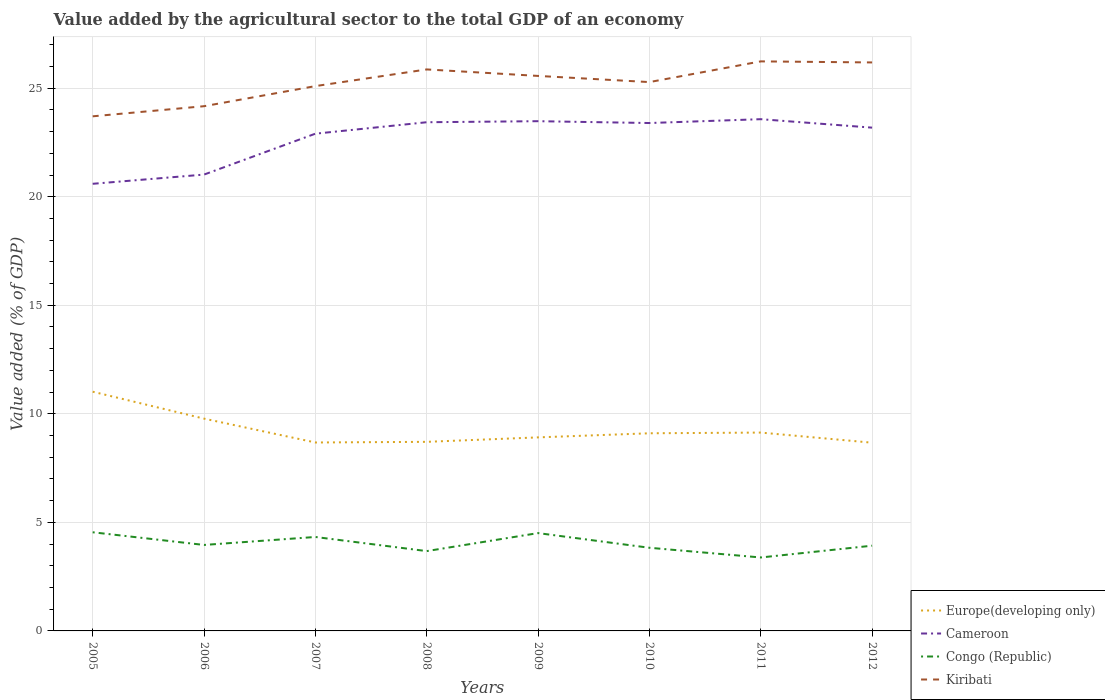How many different coloured lines are there?
Your answer should be compact. 4. Does the line corresponding to Europe(developing only) intersect with the line corresponding to Cameroon?
Give a very brief answer. No. Is the number of lines equal to the number of legend labels?
Give a very brief answer. Yes. Across all years, what is the maximum value added by the agricultural sector to the total GDP in Congo (Republic)?
Keep it short and to the point. 3.38. In which year was the value added by the agricultural sector to the total GDP in Cameroon maximum?
Your answer should be compact. 2005. What is the total value added by the agricultural sector to the total GDP in Congo (Republic) in the graph?
Keep it short and to the point. -0.37. What is the difference between the highest and the second highest value added by the agricultural sector to the total GDP in Europe(developing only)?
Offer a very short reply. 2.35. What is the difference between the highest and the lowest value added by the agricultural sector to the total GDP in Cameroon?
Keep it short and to the point. 6. How many lines are there?
Make the answer very short. 4. What is the difference between two consecutive major ticks on the Y-axis?
Your answer should be compact. 5. Does the graph contain any zero values?
Ensure brevity in your answer.  No. Does the graph contain grids?
Offer a very short reply. Yes. Where does the legend appear in the graph?
Provide a short and direct response. Bottom right. What is the title of the graph?
Offer a terse response. Value added by the agricultural sector to the total GDP of an economy. Does "World" appear as one of the legend labels in the graph?
Provide a succinct answer. No. What is the label or title of the X-axis?
Provide a short and direct response. Years. What is the label or title of the Y-axis?
Offer a terse response. Value added (% of GDP). What is the Value added (% of GDP) of Europe(developing only) in 2005?
Your answer should be very brief. 11.02. What is the Value added (% of GDP) in Cameroon in 2005?
Your answer should be compact. 20.59. What is the Value added (% of GDP) of Congo (Republic) in 2005?
Your response must be concise. 4.54. What is the Value added (% of GDP) in Kiribati in 2005?
Your answer should be compact. 23.7. What is the Value added (% of GDP) in Europe(developing only) in 2006?
Give a very brief answer. 9.78. What is the Value added (% of GDP) of Cameroon in 2006?
Your response must be concise. 21.02. What is the Value added (% of GDP) of Congo (Republic) in 2006?
Provide a short and direct response. 3.96. What is the Value added (% of GDP) in Kiribati in 2006?
Your response must be concise. 24.17. What is the Value added (% of GDP) in Europe(developing only) in 2007?
Offer a terse response. 8.68. What is the Value added (% of GDP) in Cameroon in 2007?
Your response must be concise. 22.9. What is the Value added (% of GDP) of Congo (Republic) in 2007?
Offer a terse response. 4.33. What is the Value added (% of GDP) of Kiribati in 2007?
Make the answer very short. 25.09. What is the Value added (% of GDP) of Europe(developing only) in 2008?
Provide a succinct answer. 8.71. What is the Value added (% of GDP) of Cameroon in 2008?
Keep it short and to the point. 23.43. What is the Value added (% of GDP) of Congo (Republic) in 2008?
Your answer should be compact. 3.68. What is the Value added (% of GDP) of Kiribati in 2008?
Provide a short and direct response. 25.86. What is the Value added (% of GDP) in Europe(developing only) in 2009?
Offer a terse response. 8.91. What is the Value added (% of GDP) in Cameroon in 2009?
Offer a terse response. 23.48. What is the Value added (% of GDP) in Congo (Republic) in 2009?
Provide a short and direct response. 4.51. What is the Value added (% of GDP) of Kiribati in 2009?
Offer a very short reply. 25.56. What is the Value added (% of GDP) of Europe(developing only) in 2010?
Offer a terse response. 9.1. What is the Value added (% of GDP) of Cameroon in 2010?
Your answer should be compact. 23.39. What is the Value added (% of GDP) of Congo (Republic) in 2010?
Your response must be concise. 3.83. What is the Value added (% of GDP) in Kiribati in 2010?
Give a very brief answer. 25.28. What is the Value added (% of GDP) in Europe(developing only) in 2011?
Your answer should be compact. 9.14. What is the Value added (% of GDP) in Cameroon in 2011?
Offer a very short reply. 23.57. What is the Value added (% of GDP) of Congo (Republic) in 2011?
Offer a very short reply. 3.38. What is the Value added (% of GDP) of Kiribati in 2011?
Keep it short and to the point. 26.23. What is the Value added (% of GDP) of Europe(developing only) in 2012?
Provide a succinct answer. 8.67. What is the Value added (% of GDP) in Cameroon in 2012?
Give a very brief answer. 23.18. What is the Value added (% of GDP) in Congo (Republic) in 2012?
Keep it short and to the point. 3.93. What is the Value added (% of GDP) of Kiribati in 2012?
Your response must be concise. 26.18. Across all years, what is the maximum Value added (% of GDP) of Europe(developing only)?
Your response must be concise. 11.02. Across all years, what is the maximum Value added (% of GDP) in Cameroon?
Give a very brief answer. 23.57. Across all years, what is the maximum Value added (% of GDP) of Congo (Republic)?
Keep it short and to the point. 4.54. Across all years, what is the maximum Value added (% of GDP) of Kiribati?
Make the answer very short. 26.23. Across all years, what is the minimum Value added (% of GDP) in Europe(developing only)?
Your answer should be very brief. 8.67. Across all years, what is the minimum Value added (% of GDP) in Cameroon?
Ensure brevity in your answer.  20.59. Across all years, what is the minimum Value added (% of GDP) in Congo (Republic)?
Make the answer very short. 3.38. Across all years, what is the minimum Value added (% of GDP) in Kiribati?
Your answer should be very brief. 23.7. What is the total Value added (% of GDP) of Europe(developing only) in the graph?
Make the answer very short. 74.01. What is the total Value added (% of GDP) in Cameroon in the graph?
Keep it short and to the point. 181.57. What is the total Value added (% of GDP) of Congo (Republic) in the graph?
Keep it short and to the point. 32.15. What is the total Value added (% of GDP) of Kiribati in the graph?
Give a very brief answer. 202.09. What is the difference between the Value added (% of GDP) of Europe(developing only) in 2005 and that in 2006?
Provide a succinct answer. 1.24. What is the difference between the Value added (% of GDP) of Cameroon in 2005 and that in 2006?
Offer a very short reply. -0.42. What is the difference between the Value added (% of GDP) in Congo (Republic) in 2005 and that in 2006?
Your response must be concise. 0.58. What is the difference between the Value added (% of GDP) of Kiribati in 2005 and that in 2006?
Offer a terse response. -0.47. What is the difference between the Value added (% of GDP) in Europe(developing only) in 2005 and that in 2007?
Provide a short and direct response. 2.34. What is the difference between the Value added (% of GDP) of Cameroon in 2005 and that in 2007?
Give a very brief answer. -2.31. What is the difference between the Value added (% of GDP) of Congo (Republic) in 2005 and that in 2007?
Offer a terse response. 0.22. What is the difference between the Value added (% of GDP) in Kiribati in 2005 and that in 2007?
Offer a very short reply. -1.39. What is the difference between the Value added (% of GDP) in Europe(developing only) in 2005 and that in 2008?
Keep it short and to the point. 2.31. What is the difference between the Value added (% of GDP) of Cameroon in 2005 and that in 2008?
Provide a short and direct response. -2.84. What is the difference between the Value added (% of GDP) of Congo (Republic) in 2005 and that in 2008?
Make the answer very short. 0.87. What is the difference between the Value added (% of GDP) of Kiribati in 2005 and that in 2008?
Offer a terse response. -2.16. What is the difference between the Value added (% of GDP) in Europe(developing only) in 2005 and that in 2009?
Offer a very short reply. 2.1. What is the difference between the Value added (% of GDP) of Cameroon in 2005 and that in 2009?
Your answer should be very brief. -2.88. What is the difference between the Value added (% of GDP) of Congo (Republic) in 2005 and that in 2009?
Make the answer very short. 0.04. What is the difference between the Value added (% of GDP) in Kiribati in 2005 and that in 2009?
Provide a succinct answer. -1.86. What is the difference between the Value added (% of GDP) in Europe(developing only) in 2005 and that in 2010?
Provide a succinct answer. 1.91. What is the difference between the Value added (% of GDP) in Cameroon in 2005 and that in 2010?
Your response must be concise. -2.8. What is the difference between the Value added (% of GDP) in Congo (Republic) in 2005 and that in 2010?
Make the answer very short. 0.71. What is the difference between the Value added (% of GDP) of Kiribati in 2005 and that in 2010?
Give a very brief answer. -1.58. What is the difference between the Value added (% of GDP) in Europe(developing only) in 2005 and that in 2011?
Keep it short and to the point. 1.88. What is the difference between the Value added (% of GDP) of Cameroon in 2005 and that in 2011?
Provide a short and direct response. -2.98. What is the difference between the Value added (% of GDP) of Congo (Republic) in 2005 and that in 2011?
Provide a short and direct response. 1.16. What is the difference between the Value added (% of GDP) in Kiribati in 2005 and that in 2011?
Make the answer very short. -2.53. What is the difference between the Value added (% of GDP) of Europe(developing only) in 2005 and that in 2012?
Your response must be concise. 2.35. What is the difference between the Value added (% of GDP) in Cameroon in 2005 and that in 2012?
Provide a short and direct response. -2.59. What is the difference between the Value added (% of GDP) in Congo (Republic) in 2005 and that in 2012?
Offer a very short reply. 0.62. What is the difference between the Value added (% of GDP) of Kiribati in 2005 and that in 2012?
Ensure brevity in your answer.  -2.48. What is the difference between the Value added (% of GDP) in Europe(developing only) in 2006 and that in 2007?
Provide a short and direct response. 1.1. What is the difference between the Value added (% of GDP) in Cameroon in 2006 and that in 2007?
Ensure brevity in your answer.  -1.88. What is the difference between the Value added (% of GDP) in Congo (Republic) in 2006 and that in 2007?
Give a very brief answer. -0.37. What is the difference between the Value added (% of GDP) in Kiribati in 2006 and that in 2007?
Make the answer very short. -0.93. What is the difference between the Value added (% of GDP) of Europe(developing only) in 2006 and that in 2008?
Ensure brevity in your answer.  1.07. What is the difference between the Value added (% of GDP) in Cameroon in 2006 and that in 2008?
Ensure brevity in your answer.  -2.41. What is the difference between the Value added (% of GDP) in Congo (Republic) in 2006 and that in 2008?
Your response must be concise. 0.28. What is the difference between the Value added (% of GDP) of Kiribati in 2006 and that in 2008?
Provide a succinct answer. -1.69. What is the difference between the Value added (% of GDP) in Europe(developing only) in 2006 and that in 2009?
Your answer should be very brief. 0.86. What is the difference between the Value added (% of GDP) in Cameroon in 2006 and that in 2009?
Offer a terse response. -2.46. What is the difference between the Value added (% of GDP) in Congo (Republic) in 2006 and that in 2009?
Provide a short and direct response. -0.55. What is the difference between the Value added (% of GDP) of Kiribati in 2006 and that in 2009?
Give a very brief answer. -1.4. What is the difference between the Value added (% of GDP) in Europe(developing only) in 2006 and that in 2010?
Ensure brevity in your answer.  0.67. What is the difference between the Value added (% of GDP) of Cameroon in 2006 and that in 2010?
Make the answer very short. -2.37. What is the difference between the Value added (% of GDP) of Congo (Republic) in 2006 and that in 2010?
Your answer should be very brief. 0.13. What is the difference between the Value added (% of GDP) of Kiribati in 2006 and that in 2010?
Offer a very short reply. -1.11. What is the difference between the Value added (% of GDP) of Europe(developing only) in 2006 and that in 2011?
Your answer should be compact. 0.64. What is the difference between the Value added (% of GDP) of Cameroon in 2006 and that in 2011?
Your answer should be compact. -2.55. What is the difference between the Value added (% of GDP) in Congo (Republic) in 2006 and that in 2011?
Give a very brief answer. 0.58. What is the difference between the Value added (% of GDP) of Kiribati in 2006 and that in 2011?
Make the answer very short. -2.06. What is the difference between the Value added (% of GDP) in Europe(developing only) in 2006 and that in 2012?
Offer a very short reply. 1.11. What is the difference between the Value added (% of GDP) in Cameroon in 2006 and that in 2012?
Ensure brevity in your answer.  -2.16. What is the difference between the Value added (% of GDP) in Congo (Republic) in 2006 and that in 2012?
Make the answer very short. 0.03. What is the difference between the Value added (% of GDP) of Kiribati in 2006 and that in 2012?
Keep it short and to the point. -2.02. What is the difference between the Value added (% of GDP) in Europe(developing only) in 2007 and that in 2008?
Keep it short and to the point. -0.03. What is the difference between the Value added (% of GDP) in Cameroon in 2007 and that in 2008?
Your response must be concise. -0.53. What is the difference between the Value added (% of GDP) of Congo (Republic) in 2007 and that in 2008?
Keep it short and to the point. 0.65. What is the difference between the Value added (% of GDP) in Kiribati in 2007 and that in 2008?
Provide a succinct answer. -0.77. What is the difference between the Value added (% of GDP) of Europe(developing only) in 2007 and that in 2009?
Your answer should be compact. -0.23. What is the difference between the Value added (% of GDP) in Cameroon in 2007 and that in 2009?
Ensure brevity in your answer.  -0.58. What is the difference between the Value added (% of GDP) of Congo (Republic) in 2007 and that in 2009?
Provide a succinct answer. -0.18. What is the difference between the Value added (% of GDP) of Kiribati in 2007 and that in 2009?
Offer a terse response. -0.47. What is the difference between the Value added (% of GDP) in Europe(developing only) in 2007 and that in 2010?
Offer a very short reply. -0.42. What is the difference between the Value added (% of GDP) of Cameroon in 2007 and that in 2010?
Your answer should be very brief. -0.49. What is the difference between the Value added (% of GDP) of Congo (Republic) in 2007 and that in 2010?
Offer a very short reply. 0.5. What is the difference between the Value added (% of GDP) of Kiribati in 2007 and that in 2010?
Ensure brevity in your answer.  -0.19. What is the difference between the Value added (% of GDP) in Europe(developing only) in 2007 and that in 2011?
Make the answer very short. -0.46. What is the difference between the Value added (% of GDP) of Cameroon in 2007 and that in 2011?
Offer a very short reply. -0.67. What is the difference between the Value added (% of GDP) of Congo (Republic) in 2007 and that in 2011?
Your answer should be very brief. 0.94. What is the difference between the Value added (% of GDP) in Kiribati in 2007 and that in 2011?
Offer a very short reply. -1.14. What is the difference between the Value added (% of GDP) in Europe(developing only) in 2007 and that in 2012?
Your response must be concise. 0.01. What is the difference between the Value added (% of GDP) of Cameroon in 2007 and that in 2012?
Provide a short and direct response. -0.28. What is the difference between the Value added (% of GDP) of Congo (Republic) in 2007 and that in 2012?
Offer a terse response. 0.4. What is the difference between the Value added (% of GDP) in Kiribati in 2007 and that in 2012?
Make the answer very short. -1.09. What is the difference between the Value added (% of GDP) in Europe(developing only) in 2008 and that in 2009?
Offer a very short reply. -0.21. What is the difference between the Value added (% of GDP) of Cameroon in 2008 and that in 2009?
Make the answer very short. -0.05. What is the difference between the Value added (% of GDP) of Congo (Republic) in 2008 and that in 2009?
Your answer should be compact. -0.83. What is the difference between the Value added (% of GDP) in Kiribati in 2008 and that in 2009?
Keep it short and to the point. 0.3. What is the difference between the Value added (% of GDP) in Europe(developing only) in 2008 and that in 2010?
Your answer should be very brief. -0.39. What is the difference between the Value added (% of GDP) in Cameroon in 2008 and that in 2010?
Make the answer very short. 0.04. What is the difference between the Value added (% of GDP) of Congo (Republic) in 2008 and that in 2010?
Keep it short and to the point. -0.15. What is the difference between the Value added (% of GDP) of Kiribati in 2008 and that in 2010?
Offer a terse response. 0.58. What is the difference between the Value added (% of GDP) of Europe(developing only) in 2008 and that in 2011?
Ensure brevity in your answer.  -0.43. What is the difference between the Value added (% of GDP) in Cameroon in 2008 and that in 2011?
Provide a succinct answer. -0.14. What is the difference between the Value added (% of GDP) of Congo (Republic) in 2008 and that in 2011?
Give a very brief answer. 0.29. What is the difference between the Value added (% of GDP) in Kiribati in 2008 and that in 2011?
Your response must be concise. -0.37. What is the difference between the Value added (% of GDP) of Europe(developing only) in 2008 and that in 2012?
Your answer should be very brief. 0.04. What is the difference between the Value added (% of GDP) of Cameroon in 2008 and that in 2012?
Give a very brief answer. 0.25. What is the difference between the Value added (% of GDP) in Congo (Republic) in 2008 and that in 2012?
Your answer should be very brief. -0.25. What is the difference between the Value added (% of GDP) in Kiribati in 2008 and that in 2012?
Make the answer very short. -0.32. What is the difference between the Value added (% of GDP) of Europe(developing only) in 2009 and that in 2010?
Ensure brevity in your answer.  -0.19. What is the difference between the Value added (% of GDP) of Cameroon in 2009 and that in 2010?
Provide a short and direct response. 0.08. What is the difference between the Value added (% of GDP) in Congo (Republic) in 2009 and that in 2010?
Ensure brevity in your answer.  0.68. What is the difference between the Value added (% of GDP) in Kiribati in 2009 and that in 2010?
Offer a terse response. 0.28. What is the difference between the Value added (% of GDP) of Europe(developing only) in 2009 and that in 2011?
Your answer should be very brief. -0.22. What is the difference between the Value added (% of GDP) of Cameroon in 2009 and that in 2011?
Offer a very short reply. -0.09. What is the difference between the Value added (% of GDP) of Congo (Republic) in 2009 and that in 2011?
Make the answer very short. 1.12. What is the difference between the Value added (% of GDP) in Kiribati in 2009 and that in 2011?
Provide a short and direct response. -0.67. What is the difference between the Value added (% of GDP) of Europe(developing only) in 2009 and that in 2012?
Provide a short and direct response. 0.25. What is the difference between the Value added (% of GDP) of Cameroon in 2009 and that in 2012?
Your answer should be compact. 0.3. What is the difference between the Value added (% of GDP) in Congo (Republic) in 2009 and that in 2012?
Make the answer very short. 0.58. What is the difference between the Value added (% of GDP) in Kiribati in 2009 and that in 2012?
Provide a short and direct response. -0.62. What is the difference between the Value added (% of GDP) in Europe(developing only) in 2010 and that in 2011?
Offer a very short reply. -0.03. What is the difference between the Value added (% of GDP) in Cameroon in 2010 and that in 2011?
Your answer should be very brief. -0.18. What is the difference between the Value added (% of GDP) in Congo (Republic) in 2010 and that in 2011?
Give a very brief answer. 0.45. What is the difference between the Value added (% of GDP) of Kiribati in 2010 and that in 2011?
Give a very brief answer. -0.95. What is the difference between the Value added (% of GDP) of Europe(developing only) in 2010 and that in 2012?
Give a very brief answer. 0.43. What is the difference between the Value added (% of GDP) of Cameroon in 2010 and that in 2012?
Offer a very short reply. 0.21. What is the difference between the Value added (% of GDP) of Congo (Republic) in 2010 and that in 2012?
Give a very brief answer. -0.1. What is the difference between the Value added (% of GDP) of Kiribati in 2010 and that in 2012?
Provide a succinct answer. -0.9. What is the difference between the Value added (% of GDP) of Europe(developing only) in 2011 and that in 2012?
Offer a very short reply. 0.47. What is the difference between the Value added (% of GDP) of Cameroon in 2011 and that in 2012?
Your response must be concise. 0.39. What is the difference between the Value added (% of GDP) of Congo (Republic) in 2011 and that in 2012?
Keep it short and to the point. -0.54. What is the difference between the Value added (% of GDP) of Kiribati in 2011 and that in 2012?
Give a very brief answer. 0.05. What is the difference between the Value added (% of GDP) of Europe(developing only) in 2005 and the Value added (% of GDP) of Cameroon in 2006?
Give a very brief answer. -10. What is the difference between the Value added (% of GDP) in Europe(developing only) in 2005 and the Value added (% of GDP) in Congo (Republic) in 2006?
Your answer should be very brief. 7.06. What is the difference between the Value added (% of GDP) of Europe(developing only) in 2005 and the Value added (% of GDP) of Kiribati in 2006?
Provide a succinct answer. -13.15. What is the difference between the Value added (% of GDP) in Cameroon in 2005 and the Value added (% of GDP) in Congo (Republic) in 2006?
Your answer should be very brief. 16.63. What is the difference between the Value added (% of GDP) in Cameroon in 2005 and the Value added (% of GDP) in Kiribati in 2006?
Keep it short and to the point. -3.57. What is the difference between the Value added (% of GDP) of Congo (Republic) in 2005 and the Value added (% of GDP) of Kiribati in 2006?
Offer a terse response. -19.62. What is the difference between the Value added (% of GDP) in Europe(developing only) in 2005 and the Value added (% of GDP) in Cameroon in 2007?
Provide a short and direct response. -11.88. What is the difference between the Value added (% of GDP) in Europe(developing only) in 2005 and the Value added (% of GDP) in Congo (Republic) in 2007?
Provide a short and direct response. 6.69. What is the difference between the Value added (% of GDP) of Europe(developing only) in 2005 and the Value added (% of GDP) of Kiribati in 2007?
Provide a succinct answer. -14.08. What is the difference between the Value added (% of GDP) in Cameroon in 2005 and the Value added (% of GDP) in Congo (Republic) in 2007?
Make the answer very short. 16.27. What is the difference between the Value added (% of GDP) of Cameroon in 2005 and the Value added (% of GDP) of Kiribati in 2007?
Provide a succinct answer. -4.5. What is the difference between the Value added (% of GDP) in Congo (Republic) in 2005 and the Value added (% of GDP) in Kiribati in 2007?
Make the answer very short. -20.55. What is the difference between the Value added (% of GDP) of Europe(developing only) in 2005 and the Value added (% of GDP) of Cameroon in 2008?
Your answer should be very brief. -12.41. What is the difference between the Value added (% of GDP) in Europe(developing only) in 2005 and the Value added (% of GDP) in Congo (Republic) in 2008?
Keep it short and to the point. 7.34. What is the difference between the Value added (% of GDP) in Europe(developing only) in 2005 and the Value added (% of GDP) in Kiribati in 2008?
Offer a very short reply. -14.84. What is the difference between the Value added (% of GDP) in Cameroon in 2005 and the Value added (% of GDP) in Congo (Republic) in 2008?
Provide a succinct answer. 16.92. What is the difference between the Value added (% of GDP) of Cameroon in 2005 and the Value added (% of GDP) of Kiribati in 2008?
Make the answer very short. -5.27. What is the difference between the Value added (% of GDP) in Congo (Republic) in 2005 and the Value added (% of GDP) in Kiribati in 2008?
Your answer should be very brief. -21.32. What is the difference between the Value added (% of GDP) in Europe(developing only) in 2005 and the Value added (% of GDP) in Cameroon in 2009?
Give a very brief answer. -12.46. What is the difference between the Value added (% of GDP) in Europe(developing only) in 2005 and the Value added (% of GDP) in Congo (Republic) in 2009?
Ensure brevity in your answer.  6.51. What is the difference between the Value added (% of GDP) of Europe(developing only) in 2005 and the Value added (% of GDP) of Kiribati in 2009?
Offer a very short reply. -14.55. What is the difference between the Value added (% of GDP) of Cameroon in 2005 and the Value added (% of GDP) of Congo (Republic) in 2009?
Your response must be concise. 16.09. What is the difference between the Value added (% of GDP) of Cameroon in 2005 and the Value added (% of GDP) of Kiribati in 2009?
Your answer should be compact. -4.97. What is the difference between the Value added (% of GDP) in Congo (Republic) in 2005 and the Value added (% of GDP) in Kiribati in 2009?
Your answer should be very brief. -21.02. What is the difference between the Value added (% of GDP) in Europe(developing only) in 2005 and the Value added (% of GDP) in Cameroon in 2010?
Give a very brief answer. -12.38. What is the difference between the Value added (% of GDP) in Europe(developing only) in 2005 and the Value added (% of GDP) in Congo (Republic) in 2010?
Offer a very short reply. 7.19. What is the difference between the Value added (% of GDP) of Europe(developing only) in 2005 and the Value added (% of GDP) of Kiribati in 2010?
Keep it short and to the point. -14.26. What is the difference between the Value added (% of GDP) of Cameroon in 2005 and the Value added (% of GDP) of Congo (Republic) in 2010?
Offer a very short reply. 16.76. What is the difference between the Value added (% of GDP) of Cameroon in 2005 and the Value added (% of GDP) of Kiribati in 2010?
Your response must be concise. -4.68. What is the difference between the Value added (% of GDP) in Congo (Republic) in 2005 and the Value added (% of GDP) in Kiribati in 2010?
Keep it short and to the point. -20.74. What is the difference between the Value added (% of GDP) in Europe(developing only) in 2005 and the Value added (% of GDP) in Cameroon in 2011?
Give a very brief answer. -12.55. What is the difference between the Value added (% of GDP) in Europe(developing only) in 2005 and the Value added (% of GDP) in Congo (Republic) in 2011?
Your response must be concise. 7.64. What is the difference between the Value added (% of GDP) in Europe(developing only) in 2005 and the Value added (% of GDP) in Kiribati in 2011?
Offer a terse response. -15.22. What is the difference between the Value added (% of GDP) in Cameroon in 2005 and the Value added (% of GDP) in Congo (Republic) in 2011?
Your response must be concise. 17.21. What is the difference between the Value added (% of GDP) of Cameroon in 2005 and the Value added (% of GDP) of Kiribati in 2011?
Your response must be concise. -5.64. What is the difference between the Value added (% of GDP) in Congo (Republic) in 2005 and the Value added (% of GDP) in Kiribati in 2011?
Provide a succinct answer. -21.69. What is the difference between the Value added (% of GDP) in Europe(developing only) in 2005 and the Value added (% of GDP) in Cameroon in 2012?
Offer a very short reply. -12.16. What is the difference between the Value added (% of GDP) in Europe(developing only) in 2005 and the Value added (% of GDP) in Congo (Republic) in 2012?
Ensure brevity in your answer.  7.09. What is the difference between the Value added (% of GDP) of Europe(developing only) in 2005 and the Value added (% of GDP) of Kiribati in 2012?
Offer a very short reply. -15.17. What is the difference between the Value added (% of GDP) of Cameroon in 2005 and the Value added (% of GDP) of Congo (Republic) in 2012?
Offer a terse response. 16.67. What is the difference between the Value added (% of GDP) in Cameroon in 2005 and the Value added (% of GDP) in Kiribati in 2012?
Keep it short and to the point. -5.59. What is the difference between the Value added (% of GDP) in Congo (Republic) in 2005 and the Value added (% of GDP) in Kiribati in 2012?
Offer a terse response. -21.64. What is the difference between the Value added (% of GDP) in Europe(developing only) in 2006 and the Value added (% of GDP) in Cameroon in 2007?
Your answer should be very brief. -13.13. What is the difference between the Value added (% of GDP) in Europe(developing only) in 2006 and the Value added (% of GDP) in Congo (Republic) in 2007?
Keep it short and to the point. 5.45. What is the difference between the Value added (% of GDP) of Europe(developing only) in 2006 and the Value added (% of GDP) of Kiribati in 2007?
Your answer should be very brief. -15.32. What is the difference between the Value added (% of GDP) of Cameroon in 2006 and the Value added (% of GDP) of Congo (Republic) in 2007?
Provide a short and direct response. 16.69. What is the difference between the Value added (% of GDP) in Cameroon in 2006 and the Value added (% of GDP) in Kiribati in 2007?
Offer a terse response. -4.08. What is the difference between the Value added (% of GDP) in Congo (Republic) in 2006 and the Value added (% of GDP) in Kiribati in 2007?
Your response must be concise. -21.13. What is the difference between the Value added (% of GDP) in Europe(developing only) in 2006 and the Value added (% of GDP) in Cameroon in 2008?
Keep it short and to the point. -13.65. What is the difference between the Value added (% of GDP) in Europe(developing only) in 2006 and the Value added (% of GDP) in Congo (Republic) in 2008?
Your answer should be compact. 6.1. What is the difference between the Value added (% of GDP) in Europe(developing only) in 2006 and the Value added (% of GDP) in Kiribati in 2008?
Your answer should be very brief. -16.09. What is the difference between the Value added (% of GDP) of Cameroon in 2006 and the Value added (% of GDP) of Congo (Republic) in 2008?
Provide a short and direct response. 17.34. What is the difference between the Value added (% of GDP) of Cameroon in 2006 and the Value added (% of GDP) of Kiribati in 2008?
Keep it short and to the point. -4.84. What is the difference between the Value added (% of GDP) of Congo (Republic) in 2006 and the Value added (% of GDP) of Kiribati in 2008?
Provide a succinct answer. -21.9. What is the difference between the Value added (% of GDP) in Europe(developing only) in 2006 and the Value added (% of GDP) in Cameroon in 2009?
Provide a succinct answer. -13.7. What is the difference between the Value added (% of GDP) in Europe(developing only) in 2006 and the Value added (% of GDP) in Congo (Republic) in 2009?
Make the answer very short. 5.27. What is the difference between the Value added (% of GDP) in Europe(developing only) in 2006 and the Value added (% of GDP) in Kiribati in 2009?
Keep it short and to the point. -15.79. What is the difference between the Value added (% of GDP) in Cameroon in 2006 and the Value added (% of GDP) in Congo (Republic) in 2009?
Keep it short and to the point. 16.51. What is the difference between the Value added (% of GDP) of Cameroon in 2006 and the Value added (% of GDP) of Kiribati in 2009?
Keep it short and to the point. -4.54. What is the difference between the Value added (% of GDP) of Congo (Republic) in 2006 and the Value added (% of GDP) of Kiribati in 2009?
Make the answer very short. -21.6. What is the difference between the Value added (% of GDP) of Europe(developing only) in 2006 and the Value added (% of GDP) of Cameroon in 2010?
Ensure brevity in your answer.  -13.62. What is the difference between the Value added (% of GDP) of Europe(developing only) in 2006 and the Value added (% of GDP) of Congo (Republic) in 2010?
Provide a succinct answer. 5.95. What is the difference between the Value added (% of GDP) of Europe(developing only) in 2006 and the Value added (% of GDP) of Kiribati in 2010?
Your answer should be very brief. -15.5. What is the difference between the Value added (% of GDP) of Cameroon in 2006 and the Value added (% of GDP) of Congo (Republic) in 2010?
Your answer should be very brief. 17.19. What is the difference between the Value added (% of GDP) of Cameroon in 2006 and the Value added (% of GDP) of Kiribati in 2010?
Your answer should be very brief. -4.26. What is the difference between the Value added (% of GDP) of Congo (Republic) in 2006 and the Value added (% of GDP) of Kiribati in 2010?
Your response must be concise. -21.32. What is the difference between the Value added (% of GDP) of Europe(developing only) in 2006 and the Value added (% of GDP) of Cameroon in 2011?
Your answer should be compact. -13.79. What is the difference between the Value added (% of GDP) in Europe(developing only) in 2006 and the Value added (% of GDP) in Congo (Republic) in 2011?
Provide a succinct answer. 6.39. What is the difference between the Value added (% of GDP) in Europe(developing only) in 2006 and the Value added (% of GDP) in Kiribati in 2011?
Ensure brevity in your answer.  -16.46. What is the difference between the Value added (% of GDP) of Cameroon in 2006 and the Value added (% of GDP) of Congo (Republic) in 2011?
Provide a short and direct response. 17.64. What is the difference between the Value added (% of GDP) in Cameroon in 2006 and the Value added (% of GDP) in Kiribati in 2011?
Ensure brevity in your answer.  -5.21. What is the difference between the Value added (% of GDP) in Congo (Republic) in 2006 and the Value added (% of GDP) in Kiribati in 2011?
Your answer should be very brief. -22.27. What is the difference between the Value added (% of GDP) in Europe(developing only) in 2006 and the Value added (% of GDP) in Cameroon in 2012?
Offer a very short reply. -13.4. What is the difference between the Value added (% of GDP) of Europe(developing only) in 2006 and the Value added (% of GDP) of Congo (Republic) in 2012?
Offer a terse response. 5.85. What is the difference between the Value added (% of GDP) of Europe(developing only) in 2006 and the Value added (% of GDP) of Kiribati in 2012?
Ensure brevity in your answer.  -16.41. What is the difference between the Value added (% of GDP) of Cameroon in 2006 and the Value added (% of GDP) of Congo (Republic) in 2012?
Offer a terse response. 17.09. What is the difference between the Value added (% of GDP) in Cameroon in 2006 and the Value added (% of GDP) in Kiribati in 2012?
Provide a succinct answer. -5.17. What is the difference between the Value added (% of GDP) of Congo (Republic) in 2006 and the Value added (% of GDP) of Kiribati in 2012?
Your response must be concise. -22.22. What is the difference between the Value added (% of GDP) of Europe(developing only) in 2007 and the Value added (% of GDP) of Cameroon in 2008?
Keep it short and to the point. -14.75. What is the difference between the Value added (% of GDP) in Europe(developing only) in 2007 and the Value added (% of GDP) in Congo (Republic) in 2008?
Keep it short and to the point. 5. What is the difference between the Value added (% of GDP) of Europe(developing only) in 2007 and the Value added (% of GDP) of Kiribati in 2008?
Offer a very short reply. -17.18. What is the difference between the Value added (% of GDP) of Cameroon in 2007 and the Value added (% of GDP) of Congo (Republic) in 2008?
Your answer should be very brief. 19.23. What is the difference between the Value added (% of GDP) in Cameroon in 2007 and the Value added (% of GDP) in Kiribati in 2008?
Provide a short and direct response. -2.96. What is the difference between the Value added (% of GDP) in Congo (Republic) in 2007 and the Value added (% of GDP) in Kiribati in 2008?
Your answer should be very brief. -21.54. What is the difference between the Value added (% of GDP) of Europe(developing only) in 2007 and the Value added (% of GDP) of Cameroon in 2009?
Offer a very short reply. -14.8. What is the difference between the Value added (% of GDP) in Europe(developing only) in 2007 and the Value added (% of GDP) in Congo (Republic) in 2009?
Provide a short and direct response. 4.17. What is the difference between the Value added (% of GDP) in Europe(developing only) in 2007 and the Value added (% of GDP) in Kiribati in 2009?
Your response must be concise. -16.88. What is the difference between the Value added (% of GDP) of Cameroon in 2007 and the Value added (% of GDP) of Congo (Republic) in 2009?
Provide a succinct answer. 18.4. What is the difference between the Value added (% of GDP) in Cameroon in 2007 and the Value added (% of GDP) in Kiribati in 2009?
Provide a succinct answer. -2.66. What is the difference between the Value added (% of GDP) of Congo (Republic) in 2007 and the Value added (% of GDP) of Kiribati in 2009?
Offer a terse response. -21.24. What is the difference between the Value added (% of GDP) of Europe(developing only) in 2007 and the Value added (% of GDP) of Cameroon in 2010?
Provide a succinct answer. -14.71. What is the difference between the Value added (% of GDP) in Europe(developing only) in 2007 and the Value added (% of GDP) in Congo (Republic) in 2010?
Offer a terse response. 4.85. What is the difference between the Value added (% of GDP) in Europe(developing only) in 2007 and the Value added (% of GDP) in Kiribati in 2010?
Give a very brief answer. -16.6. What is the difference between the Value added (% of GDP) in Cameroon in 2007 and the Value added (% of GDP) in Congo (Republic) in 2010?
Your response must be concise. 19.07. What is the difference between the Value added (% of GDP) of Cameroon in 2007 and the Value added (% of GDP) of Kiribati in 2010?
Provide a short and direct response. -2.38. What is the difference between the Value added (% of GDP) of Congo (Republic) in 2007 and the Value added (% of GDP) of Kiribati in 2010?
Your answer should be compact. -20.95. What is the difference between the Value added (% of GDP) in Europe(developing only) in 2007 and the Value added (% of GDP) in Cameroon in 2011?
Provide a short and direct response. -14.89. What is the difference between the Value added (% of GDP) of Europe(developing only) in 2007 and the Value added (% of GDP) of Congo (Republic) in 2011?
Provide a succinct answer. 5.3. What is the difference between the Value added (% of GDP) of Europe(developing only) in 2007 and the Value added (% of GDP) of Kiribati in 2011?
Make the answer very short. -17.55. What is the difference between the Value added (% of GDP) of Cameroon in 2007 and the Value added (% of GDP) of Congo (Republic) in 2011?
Your answer should be compact. 19.52. What is the difference between the Value added (% of GDP) of Cameroon in 2007 and the Value added (% of GDP) of Kiribati in 2011?
Your answer should be very brief. -3.33. What is the difference between the Value added (% of GDP) in Congo (Republic) in 2007 and the Value added (% of GDP) in Kiribati in 2011?
Your answer should be compact. -21.91. What is the difference between the Value added (% of GDP) of Europe(developing only) in 2007 and the Value added (% of GDP) of Cameroon in 2012?
Ensure brevity in your answer.  -14.5. What is the difference between the Value added (% of GDP) in Europe(developing only) in 2007 and the Value added (% of GDP) in Congo (Republic) in 2012?
Provide a short and direct response. 4.75. What is the difference between the Value added (% of GDP) in Europe(developing only) in 2007 and the Value added (% of GDP) in Kiribati in 2012?
Your answer should be compact. -17.5. What is the difference between the Value added (% of GDP) of Cameroon in 2007 and the Value added (% of GDP) of Congo (Republic) in 2012?
Your answer should be very brief. 18.98. What is the difference between the Value added (% of GDP) in Cameroon in 2007 and the Value added (% of GDP) in Kiribati in 2012?
Offer a terse response. -3.28. What is the difference between the Value added (% of GDP) in Congo (Republic) in 2007 and the Value added (% of GDP) in Kiribati in 2012?
Give a very brief answer. -21.86. What is the difference between the Value added (% of GDP) in Europe(developing only) in 2008 and the Value added (% of GDP) in Cameroon in 2009?
Your answer should be compact. -14.77. What is the difference between the Value added (% of GDP) in Europe(developing only) in 2008 and the Value added (% of GDP) in Congo (Republic) in 2009?
Ensure brevity in your answer.  4.2. What is the difference between the Value added (% of GDP) in Europe(developing only) in 2008 and the Value added (% of GDP) in Kiribati in 2009?
Offer a terse response. -16.85. What is the difference between the Value added (% of GDP) of Cameroon in 2008 and the Value added (% of GDP) of Congo (Republic) in 2009?
Ensure brevity in your answer.  18.92. What is the difference between the Value added (% of GDP) in Cameroon in 2008 and the Value added (% of GDP) in Kiribati in 2009?
Ensure brevity in your answer.  -2.13. What is the difference between the Value added (% of GDP) in Congo (Republic) in 2008 and the Value added (% of GDP) in Kiribati in 2009?
Ensure brevity in your answer.  -21.89. What is the difference between the Value added (% of GDP) of Europe(developing only) in 2008 and the Value added (% of GDP) of Cameroon in 2010?
Your answer should be compact. -14.68. What is the difference between the Value added (% of GDP) of Europe(developing only) in 2008 and the Value added (% of GDP) of Congo (Republic) in 2010?
Give a very brief answer. 4.88. What is the difference between the Value added (% of GDP) of Europe(developing only) in 2008 and the Value added (% of GDP) of Kiribati in 2010?
Your answer should be very brief. -16.57. What is the difference between the Value added (% of GDP) of Cameroon in 2008 and the Value added (% of GDP) of Congo (Republic) in 2010?
Your response must be concise. 19.6. What is the difference between the Value added (% of GDP) of Cameroon in 2008 and the Value added (% of GDP) of Kiribati in 2010?
Offer a very short reply. -1.85. What is the difference between the Value added (% of GDP) in Congo (Republic) in 2008 and the Value added (% of GDP) in Kiribati in 2010?
Provide a succinct answer. -21.6. What is the difference between the Value added (% of GDP) of Europe(developing only) in 2008 and the Value added (% of GDP) of Cameroon in 2011?
Provide a succinct answer. -14.86. What is the difference between the Value added (% of GDP) in Europe(developing only) in 2008 and the Value added (% of GDP) in Congo (Republic) in 2011?
Make the answer very short. 5.33. What is the difference between the Value added (% of GDP) in Europe(developing only) in 2008 and the Value added (% of GDP) in Kiribati in 2011?
Your answer should be very brief. -17.52. What is the difference between the Value added (% of GDP) of Cameroon in 2008 and the Value added (% of GDP) of Congo (Republic) in 2011?
Offer a terse response. 20.05. What is the difference between the Value added (% of GDP) of Cameroon in 2008 and the Value added (% of GDP) of Kiribati in 2011?
Give a very brief answer. -2.8. What is the difference between the Value added (% of GDP) in Congo (Republic) in 2008 and the Value added (% of GDP) in Kiribati in 2011?
Your answer should be compact. -22.56. What is the difference between the Value added (% of GDP) in Europe(developing only) in 2008 and the Value added (% of GDP) in Cameroon in 2012?
Offer a very short reply. -14.47. What is the difference between the Value added (% of GDP) of Europe(developing only) in 2008 and the Value added (% of GDP) of Congo (Republic) in 2012?
Your answer should be very brief. 4.78. What is the difference between the Value added (% of GDP) in Europe(developing only) in 2008 and the Value added (% of GDP) in Kiribati in 2012?
Provide a short and direct response. -17.48. What is the difference between the Value added (% of GDP) of Cameroon in 2008 and the Value added (% of GDP) of Congo (Republic) in 2012?
Offer a very short reply. 19.5. What is the difference between the Value added (% of GDP) in Cameroon in 2008 and the Value added (% of GDP) in Kiribati in 2012?
Your answer should be compact. -2.75. What is the difference between the Value added (% of GDP) in Congo (Republic) in 2008 and the Value added (% of GDP) in Kiribati in 2012?
Offer a terse response. -22.51. What is the difference between the Value added (% of GDP) in Europe(developing only) in 2009 and the Value added (% of GDP) in Cameroon in 2010?
Offer a very short reply. -14.48. What is the difference between the Value added (% of GDP) of Europe(developing only) in 2009 and the Value added (% of GDP) of Congo (Republic) in 2010?
Your answer should be compact. 5.08. What is the difference between the Value added (% of GDP) of Europe(developing only) in 2009 and the Value added (% of GDP) of Kiribati in 2010?
Provide a succinct answer. -16.37. What is the difference between the Value added (% of GDP) in Cameroon in 2009 and the Value added (% of GDP) in Congo (Republic) in 2010?
Your answer should be very brief. 19.65. What is the difference between the Value added (% of GDP) of Cameroon in 2009 and the Value added (% of GDP) of Kiribati in 2010?
Give a very brief answer. -1.8. What is the difference between the Value added (% of GDP) of Congo (Republic) in 2009 and the Value added (% of GDP) of Kiribati in 2010?
Offer a very short reply. -20.77. What is the difference between the Value added (% of GDP) in Europe(developing only) in 2009 and the Value added (% of GDP) in Cameroon in 2011?
Provide a short and direct response. -14.66. What is the difference between the Value added (% of GDP) in Europe(developing only) in 2009 and the Value added (% of GDP) in Congo (Republic) in 2011?
Provide a short and direct response. 5.53. What is the difference between the Value added (% of GDP) of Europe(developing only) in 2009 and the Value added (% of GDP) of Kiribati in 2011?
Offer a terse response. -17.32. What is the difference between the Value added (% of GDP) in Cameroon in 2009 and the Value added (% of GDP) in Congo (Republic) in 2011?
Provide a short and direct response. 20.1. What is the difference between the Value added (% of GDP) in Cameroon in 2009 and the Value added (% of GDP) in Kiribati in 2011?
Offer a very short reply. -2.75. What is the difference between the Value added (% of GDP) of Congo (Republic) in 2009 and the Value added (% of GDP) of Kiribati in 2011?
Offer a terse response. -21.73. What is the difference between the Value added (% of GDP) in Europe(developing only) in 2009 and the Value added (% of GDP) in Cameroon in 2012?
Offer a terse response. -14.27. What is the difference between the Value added (% of GDP) in Europe(developing only) in 2009 and the Value added (% of GDP) in Congo (Republic) in 2012?
Keep it short and to the point. 4.99. What is the difference between the Value added (% of GDP) of Europe(developing only) in 2009 and the Value added (% of GDP) of Kiribati in 2012?
Offer a terse response. -17.27. What is the difference between the Value added (% of GDP) of Cameroon in 2009 and the Value added (% of GDP) of Congo (Republic) in 2012?
Offer a very short reply. 19.55. What is the difference between the Value added (% of GDP) of Cameroon in 2009 and the Value added (% of GDP) of Kiribati in 2012?
Ensure brevity in your answer.  -2.71. What is the difference between the Value added (% of GDP) of Congo (Republic) in 2009 and the Value added (% of GDP) of Kiribati in 2012?
Your answer should be compact. -21.68. What is the difference between the Value added (% of GDP) in Europe(developing only) in 2010 and the Value added (% of GDP) in Cameroon in 2011?
Provide a short and direct response. -14.47. What is the difference between the Value added (% of GDP) of Europe(developing only) in 2010 and the Value added (% of GDP) of Congo (Republic) in 2011?
Offer a terse response. 5.72. What is the difference between the Value added (% of GDP) in Europe(developing only) in 2010 and the Value added (% of GDP) in Kiribati in 2011?
Your answer should be compact. -17.13. What is the difference between the Value added (% of GDP) of Cameroon in 2010 and the Value added (% of GDP) of Congo (Republic) in 2011?
Your answer should be very brief. 20.01. What is the difference between the Value added (% of GDP) in Cameroon in 2010 and the Value added (% of GDP) in Kiribati in 2011?
Your response must be concise. -2.84. What is the difference between the Value added (% of GDP) of Congo (Republic) in 2010 and the Value added (% of GDP) of Kiribati in 2011?
Ensure brevity in your answer.  -22.4. What is the difference between the Value added (% of GDP) in Europe(developing only) in 2010 and the Value added (% of GDP) in Cameroon in 2012?
Provide a short and direct response. -14.08. What is the difference between the Value added (% of GDP) of Europe(developing only) in 2010 and the Value added (% of GDP) of Congo (Republic) in 2012?
Keep it short and to the point. 5.18. What is the difference between the Value added (% of GDP) of Europe(developing only) in 2010 and the Value added (% of GDP) of Kiribati in 2012?
Ensure brevity in your answer.  -17.08. What is the difference between the Value added (% of GDP) of Cameroon in 2010 and the Value added (% of GDP) of Congo (Republic) in 2012?
Make the answer very short. 19.47. What is the difference between the Value added (% of GDP) of Cameroon in 2010 and the Value added (% of GDP) of Kiribati in 2012?
Offer a very short reply. -2.79. What is the difference between the Value added (% of GDP) of Congo (Republic) in 2010 and the Value added (% of GDP) of Kiribati in 2012?
Provide a short and direct response. -22.35. What is the difference between the Value added (% of GDP) in Europe(developing only) in 2011 and the Value added (% of GDP) in Cameroon in 2012?
Your response must be concise. -14.05. What is the difference between the Value added (% of GDP) in Europe(developing only) in 2011 and the Value added (% of GDP) in Congo (Republic) in 2012?
Offer a terse response. 5.21. What is the difference between the Value added (% of GDP) of Europe(developing only) in 2011 and the Value added (% of GDP) of Kiribati in 2012?
Give a very brief answer. -17.05. What is the difference between the Value added (% of GDP) in Cameroon in 2011 and the Value added (% of GDP) in Congo (Republic) in 2012?
Provide a short and direct response. 19.65. What is the difference between the Value added (% of GDP) in Cameroon in 2011 and the Value added (% of GDP) in Kiribati in 2012?
Your answer should be very brief. -2.61. What is the difference between the Value added (% of GDP) of Congo (Republic) in 2011 and the Value added (% of GDP) of Kiribati in 2012?
Provide a succinct answer. -22.8. What is the average Value added (% of GDP) of Europe(developing only) per year?
Make the answer very short. 9.25. What is the average Value added (% of GDP) of Cameroon per year?
Your answer should be very brief. 22.7. What is the average Value added (% of GDP) of Congo (Republic) per year?
Make the answer very short. 4.02. What is the average Value added (% of GDP) in Kiribati per year?
Provide a short and direct response. 25.26. In the year 2005, what is the difference between the Value added (% of GDP) of Europe(developing only) and Value added (% of GDP) of Cameroon?
Provide a succinct answer. -9.58. In the year 2005, what is the difference between the Value added (% of GDP) of Europe(developing only) and Value added (% of GDP) of Congo (Republic)?
Ensure brevity in your answer.  6.47. In the year 2005, what is the difference between the Value added (% of GDP) of Europe(developing only) and Value added (% of GDP) of Kiribati?
Ensure brevity in your answer.  -12.68. In the year 2005, what is the difference between the Value added (% of GDP) of Cameroon and Value added (% of GDP) of Congo (Republic)?
Your answer should be very brief. 16.05. In the year 2005, what is the difference between the Value added (% of GDP) in Cameroon and Value added (% of GDP) in Kiribati?
Your answer should be very brief. -3.11. In the year 2005, what is the difference between the Value added (% of GDP) in Congo (Republic) and Value added (% of GDP) in Kiribati?
Provide a succinct answer. -19.16. In the year 2006, what is the difference between the Value added (% of GDP) of Europe(developing only) and Value added (% of GDP) of Cameroon?
Your answer should be compact. -11.24. In the year 2006, what is the difference between the Value added (% of GDP) of Europe(developing only) and Value added (% of GDP) of Congo (Republic)?
Provide a succinct answer. 5.82. In the year 2006, what is the difference between the Value added (% of GDP) in Europe(developing only) and Value added (% of GDP) in Kiribati?
Your answer should be compact. -14.39. In the year 2006, what is the difference between the Value added (% of GDP) of Cameroon and Value added (% of GDP) of Congo (Republic)?
Your answer should be compact. 17.06. In the year 2006, what is the difference between the Value added (% of GDP) in Cameroon and Value added (% of GDP) in Kiribati?
Your answer should be compact. -3.15. In the year 2006, what is the difference between the Value added (% of GDP) of Congo (Republic) and Value added (% of GDP) of Kiribati?
Offer a terse response. -20.21. In the year 2007, what is the difference between the Value added (% of GDP) of Europe(developing only) and Value added (% of GDP) of Cameroon?
Give a very brief answer. -14.22. In the year 2007, what is the difference between the Value added (% of GDP) in Europe(developing only) and Value added (% of GDP) in Congo (Republic)?
Give a very brief answer. 4.35. In the year 2007, what is the difference between the Value added (% of GDP) in Europe(developing only) and Value added (% of GDP) in Kiribati?
Give a very brief answer. -16.41. In the year 2007, what is the difference between the Value added (% of GDP) of Cameroon and Value added (% of GDP) of Congo (Republic)?
Give a very brief answer. 18.58. In the year 2007, what is the difference between the Value added (% of GDP) of Cameroon and Value added (% of GDP) of Kiribati?
Your answer should be very brief. -2.19. In the year 2007, what is the difference between the Value added (% of GDP) in Congo (Republic) and Value added (% of GDP) in Kiribati?
Offer a very short reply. -20.77. In the year 2008, what is the difference between the Value added (% of GDP) of Europe(developing only) and Value added (% of GDP) of Cameroon?
Keep it short and to the point. -14.72. In the year 2008, what is the difference between the Value added (% of GDP) in Europe(developing only) and Value added (% of GDP) in Congo (Republic)?
Offer a very short reply. 5.03. In the year 2008, what is the difference between the Value added (% of GDP) of Europe(developing only) and Value added (% of GDP) of Kiribati?
Make the answer very short. -17.15. In the year 2008, what is the difference between the Value added (% of GDP) in Cameroon and Value added (% of GDP) in Congo (Republic)?
Offer a terse response. 19.75. In the year 2008, what is the difference between the Value added (% of GDP) in Cameroon and Value added (% of GDP) in Kiribati?
Provide a short and direct response. -2.43. In the year 2008, what is the difference between the Value added (% of GDP) in Congo (Republic) and Value added (% of GDP) in Kiribati?
Provide a succinct answer. -22.19. In the year 2009, what is the difference between the Value added (% of GDP) in Europe(developing only) and Value added (% of GDP) in Cameroon?
Offer a very short reply. -14.56. In the year 2009, what is the difference between the Value added (% of GDP) in Europe(developing only) and Value added (% of GDP) in Congo (Republic)?
Give a very brief answer. 4.41. In the year 2009, what is the difference between the Value added (% of GDP) of Europe(developing only) and Value added (% of GDP) of Kiribati?
Provide a short and direct response. -16.65. In the year 2009, what is the difference between the Value added (% of GDP) in Cameroon and Value added (% of GDP) in Congo (Republic)?
Ensure brevity in your answer.  18.97. In the year 2009, what is the difference between the Value added (% of GDP) of Cameroon and Value added (% of GDP) of Kiribati?
Offer a very short reply. -2.09. In the year 2009, what is the difference between the Value added (% of GDP) in Congo (Republic) and Value added (% of GDP) in Kiribati?
Make the answer very short. -21.06. In the year 2010, what is the difference between the Value added (% of GDP) of Europe(developing only) and Value added (% of GDP) of Cameroon?
Your response must be concise. -14.29. In the year 2010, what is the difference between the Value added (% of GDP) of Europe(developing only) and Value added (% of GDP) of Congo (Republic)?
Ensure brevity in your answer.  5.27. In the year 2010, what is the difference between the Value added (% of GDP) of Europe(developing only) and Value added (% of GDP) of Kiribati?
Your answer should be compact. -16.18. In the year 2010, what is the difference between the Value added (% of GDP) in Cameroon and Value added (% of GDP) in Congo (Republic)?
Your answer should be compact. 19.56. In the year 2010, what is the difference between the Value added (% of GDP) of Cameroon and Value added (% of GDP) of Kiribati?
Provide a succinct answer. -1.89. In the year 2010, what is the difference between the Value added (% of GDP) in Congo (Republic) and Value added (% of GDP) in Kiribati?
Give a very brief answer. -21.45. In the year 2011, what is the difference between the Value added (% of GDP) in Europe(developing only) and Value added (% of GDP) in Cameroon?
Keep it short and to the point. -14.44. In the year 2011, what is the difference between the Value added (% of GDP) in Europe(developing only) and Value added (% of GDP) in Congo (Republic)?
Make the answer very short. 5.75. In the year 2011, what is the difference between the Value added (% of GDP) of Europe(developing only) and Value added (% of GDP) of Kiribati?
Give a very brief answer. -17.1. In the year 2011, what is the difference between the Value added (% of GDP) in Cameroon and Value added (% of GDP) in Congo (Republic)?
Give a very brief answer. 20.19. In the year 2011, what is the difference between the Value added (% of GDP) in Cameroon and Value added (% of GDP) in Kiribati?
Your answer should be compact. -2.66. In the year 2011, what is the difference between the Value added (% of GDP) in Congo (Republic) and Value added (% of GDP) in Kiribati?
Offer a terse response. -22.85. In the year 2012, what is the difference between the Value added (% of GDP) in Europe(developing only) and Value added (% of GDP) in Cameroon?
Your answer should be very brief. -14.51. In the year 2012, what is the difference between the Value added (% of GDP) of Europe(developing only) and Value added (% of GDP) of Congo (Republic)?
Your answer should be compact. 4.74. In the year 2012, what is the difference between the Value added (% of GDP) in Europe(developing only) and Value added (% of GDP) in Kiribati?
Provide a succinct answer. -17.52. In the year 2012, what is the difference between the Value added (% of GDP) of Cameroon and Value added (% of GDP) of Congo (Republic)?
Give a very brief answer. 19.26. In the year 2012, what is the difference between the Value added (% of GDP) in Cameroon and Value added (% of GDP) in Kiribati?
Ensure brevity in your answer.  -3. In the year 2012, what is the difference between the Value added (% of GDP) in Congo (Republic) and Value added (% of GDP) in Kiribati?
Provide a succinct answer. -22.26. What is the ratio of the Value added (% of GDP) of Europe(developing only) in 2005 to that in 2006?
Provide a succinct answer. 1.13. What is the ratio of the Value added (% of GDP) in Cameroon in 2005 to that in 2006?
Your answer should be very brief. 0.98. What is the ratio of the Value added (% of GDP) in Congo (Republic) in 2005 to that in 2006?
Ensure brevity in your answer.  1.15. What is the ratio of the Value added (% of GDP) in Kiribati in 2005 to that in 2006?
Ensure brevity in your answer.  0.98. What is the ratio of the Value added (% of GDP) of Europe(developing only) in 2005 to that in 2007?
Your response must be concise. 1.27. What is the ratio of the Value added (% of GDP) of Cameroon in 2005 to that in 2007?
Ensure brevity in your answer.  0.9. What is the ratio of the Value added (% of GDP) in Congo (Republic) in 2005 to that in 2007?
Keep it short and to the point. 1.05. What is the ratio of the Value added (% of GDP) in Kiribati in 2005 to that in 2007?
Your answer should be very brief. 0.94. What is the ratio of the Value added (% of GDP) of Europe(developing only) in 2005 to that in 2008?
Provide a short and direct response. 1.27. What is the ratio of the Value added (% of GDP) in Cameroon in 2005 to that in 2008?
Keep it short and to the point. 0.88. What is the ratio of the Value added (% of GDP) of Congo (Republic) in 2005 to that in 2008?
Your answer should be compact. 1.24. What is the ratio of the Value added (% of GDP) in Kiribati in 2005 to that in 2008?
Your response must be concise. 0.92. What is the ratio of the Value added (% of GDP) in Europe(developing only) in 2005 to that in 2009?
Your answer should be very brief. 1.24. What is the ratio of the Value added (% of GDP) of Cameroon in 2005 to that in 2009?
Your response must be concise. 0.88. What is the ratio of the Value added (% of GDP) of Congo (Republic) in 2005 to that in 2009?
Your response must be concise. 1.01. What is the ratio of the Value added (% of GDP) in Kiribati in 2005 to that in 2009?
Offer a terse response. 0.93. What is the ratio of the Value added (% of GDP) in Europe(developing only) in 2005 to that in 2010?
Provide a short and direct response. 1.21. What is the ratio of the Value added (% of GDP) of Cameroon in 2005 to that in 2010?
Provide a succinct answer. 0.88. What is the ratio of the Value added (% of GDP) of Congo (Republic) in 2005 to that in 2010?
Make the answer very short. 1.19. What is the ratio of the Value added (% of GDP) in Kiribati in 2005 to that in 2010?
Your answer should be very brief. 0.94. What is the ratio of the Value added (% of GDP) in Europe(developing only) in 2005 to that in 2011?
Provide a short and direct response. 1.21. What is the ratio of the Value added (% of GDP) of Cameroon in 2005 to that in 2011?
Your response must be concise. 0.87. What is the ratio of the Value added (% of GDP) of Congo (Republic) in 2005 to that in 2011?
Your response must be concise. 1.34. What is the ratio of the Value added (% of GDP) in Kiribati in 2005 to that in 2011?
Give a very brief answer. 0.9. What is the ratio of the Value added (% of GDP) in Europe(developing only) in 2005 to that in 2012?
Offer a very short reply. 1.27. What is the ratio of the Value added (% of GDP) in Cameroon in 2005 to that in 2012?
Your answer should be very brief. 0.89. What is the ratio of the Value added (% of GDP) in Congo (Republic) in 2005 to that in 2012?
Your answer should be very brief. 1.16. What is the ratio of the Value added (% of GDP) in Kiribati in 2005 to that in 2012?
Make the answer very short. 0.91. What is the ratio of the Value added (% of GDP) in Europe(developing only) in 2006 to that in 2007?
Offer a terse response. 1.13. What is the ratio of the Value added (% of GDP) of Cameroon in 2006 to that in 2007?
Make the answer very short. 0.92. What is the ratio of the Value added (% of GDP) in Congo (Republic) in 2006 to that in 2007?
Provide a short and direct response. 0.92. What is the ratio of the Value added (% of GDP) of Kiribati in 2006 to that in 2007?
Your answer should be compact. 0.96. What is the ratio of the Value added (% of GDP) in Europe(developing only) in 2006 to that in 2008?
Make the answer very short. 1.12. What is the ratio of the Value added (% of GDP) in Cameroon in 2006 to that in 2008?
Your answer should be very brief. 0.9. What is the ratio of the Value added (% of GDP) in Congo (Republic) in 2006 to that in 2008?
Keep it short and to the point. 1.08. What is the ratio of the Value added (% of GDP) of Kiribati in 2006 to that in 2008?
Offer a terse response. 0.93. What is the ratio of the Value added (% of GDP) in Europe(developing only) in 2006 to that in 2009?
Offer a terse response. 1.1. What is the ratio of the Value added (% of GDP) of Cameroon in 2006 to that in 2009?
Your answer should be very brief. 0.9. What is the ratio of the Value added (% of GDP) in Congo (Republic) in 2006 to that in 2009?
Your answer should be very brief. 0.88. What is the ratio of the Value added (% of GDP) in Kiribati in 2006 to that in 2009?
Provide a short and direct response. 0.95. What is the ratio of the Value added (% of GDP) in Europe(developing only) in 2006 to that in 2010?
Your answer should be very brief. 1.07. What is the ratio of the Value added (% of GDP) in Cameroon in 2006 to that in 2010?
Your response must be concise. 0.9. What is the ratio of the Value added (% of GDP) in Congo (Republic) in 2006 to that in 2010?
Keep it short and to the point. 1.03. What is the ratio of the Value added (% of GDP) in Kiribati in 2006 to that in 2010?
Offer a very short reply. 0.96. What is the ratio of the Value added (% of GDP) of Europe(developing only) in 2006 to that in 2011?
Offer a very short reply. 1.07. What is the ratio of the Value added (% of GDP) of Cameroon in 2006 to that in 2011?
Keep it short and to the point. 0.89. What is the ratio of the Value added (% of GDP) in Congo (Republic) in 2006 to that in 2011?
Your response must be concise. 1.17. What is the ratio of the Value added (% of GDP) in Kiribati in 2006 to that in 2011?
Make the answer very short. 0.92. What is the ratio of the Value added (% of GDP) in Europe(developing only) in 2006 to that in 2012?
Your answer should be compact. 1.13. What is the ratio of the Value added (% of GDP) in Cameroon in 2006 to that in 2012?
Give a very brief answer. 0.91. What is the ratio of the Value added (% of GDP) of Congo (Republic) in 2006 to that in 2012?
Provide a succinct answer. 1.01. What is the ratio of the Value added (% of GDP) in Kiribati in 2006 to that in 2012?
Make the answer very short. 0.92. What is the ratio of the Value added (% of GDP) of Cameroon in 2007 to that in 2008?
Your answer should be compact. 0.98. What is the ratio of the Value added (% of GDP) of Congo (Republic) in 2007 to that in 2008?
Offer a terse response. 1.18. What is the ratio of the Value added (% of GDP) in Kiribati in 2007 to that in 2008?
Your answer should be very brief. 0.97. What is the ratio of the Value added (% of GDP) of Europe(developing only) in 2007 to that in 2009?
Your response must be concise. 0.97. What is the ratio of the Value added (% of GDP) of Cameroon in 2007 to that in 2009?
Ensure brevity in your answer.  0.98. What is the ratio of the Value added (% of GDP) of Congo (Republic) in 2007 to that in 2009?
Ensure brevity in your answer.  0.96. What is the ratio of the Value added (% of GDP) of Kiribati in 2007 to that in 2009?
Provide a succinct answer. 0.98. What is the ratio of the Value added (% of GDP) in Europe(developing only) in 2007 to that in 2010?
Offer a very short reply. 0.95. What is the ratio of the Value added (% of GDP) in Cameroon in 2007 to that in 2010?
Provide a short and direct response. 0.98. What is the ratio of the Value added (% of GDP) of Congo (Republic) in 2007 to that in 2010?
Provide a short and direct response. 1.13. What is the ratio of the Value added (% of GDP) of Kiribati in 2007 to that in 2010?
Keep it short and to the point. 0.99. What is the ratio of the Value added (% of GDP) in Europe(developing only) in 2007 to that in 2011?
Keep it short and to the point. 0.95. What is the ratio of the Value added (% of GDP) of Cameroon in 2007 to that in 2011?
Your answer should be compact. 0.97. What is the ratio of the Value added (% of GDP) in Congo (Republic) in 2007 to that in 2011?
Your answer should be very brief. 1.28. What is the ratio of the Value added (% of GDP) of Kiribati in 2007 to that in 2011?
Offer a terse response. 0.96. What is the ratio of the Value added (% of GDP) in Cameroon in 2007 to that in 2012?
Offer a terse response. 0.99. What is the ratio of the Value added (% of GDP) in Congo (Republic) in 2007 to that in 2012?
Ensure brevity in your answer.  1.1. What is the ratio of the Value added (% of GDP) in Kiribati in 2007 to that in 2012?
Your response must be concise. 0.96. What is the ratio of the Value added (% of GDP) of Europe(developing only) in 2008 to that in 2009?
Your answer should be compact. 0.98. What is the ratio of the Value added (% of GDP) in Congo (Republic) in 2008 to that in 2009?
Keep it short and to the point. 0.82. What is the ratio of the Value added (% of GDP) in Kiribati in 2008 to that in 2009?
Ensure brevity in your answer.  1.01. What is the ratio of the Value added (% of GDP) in Europe(developing only) in 2008 to that in 2010?
Offer a terse response. 0.96. What is the ratio of the Value added (% of GDP) in Congo (Republic) in 2008 to that in 2010?
Your response must be concise. 0.96. What is the ratio of the Value added (% of GDP) in Kiribati in 2008 to that in 2010?
Your answer should be compact. 1.02. What is the ratio of the Value added (% of GDP) in Europe(developing only) in 2008 to that in 2011?
Offer a very short reply. 0.95. What is the ratio of the Value added (% of GDP) in Cameroon in 2008 to that in 2011?
Keep it short and to the point. 0.99. What is the ratio of the Value added (% of GDP) of Congo (Republic) in 2008 to that in 2011?
Your answer should be very brief. 1.09. What is the ratio of the Value added (% of GDP) in Kiribati in 2008 to that in 2011?
Offer a very short reply. 0.99. What is the ratio of the Value added (% of GDP) of Europe(developing only) in 2008 to that in 2012?
Give a very brief answer. 1. What is the ratio of the Value added (% of GDP) of Cameroon in 2008 to that in 2012?
Your answer should be very brief. 1.01. What is the ratio of the Value added (% of GDP) in Congo (Republic) in 2008 to that in 2012?
Provide a short and direct response. 0.94. What is the ratio of the Value added (% of GDP) of Kiribati in 2008 to that in 2012?
Ensure brevity in your answer.  0.99. What is the ratio of the Value added (% of GDP) of Europe(developing only) in 2009 to that in 2010?
Offer a very short reply. 0.98. What is the ratio of the Value added (% of GDP) of Congo (Republic) in 2009 to that in 2010?
Keep it short and to the point. 1.18. What is the ratio of the Value added (% of GDP) in Kiribati in 2009 to that in 2010?
Provide a succinct answer. 1.01. What is the ratio of the Value added (% of GDP) of Europe(developing only) in 2009 to that in 2011?
Your response must be concise. 0.98. What is the ratio of the Value added (% of GDP) in Cameroon in 2009 to that in 2011?
Offer a very short reply. 1. What is the ratio of the Value added (% of GDP) in Congo (Republic) in 2009 to that in 2011?
Make the answer very short. 1.33. What is the ratio of the Value added (% of GDP) in Kiribati in 2009 to that in 2011?
Keep it short and to the point. 0.97. What is the ratio of the Value added (% of GDP) in Europe(developing only) in 2009 to that in 2012?
Your answer should be compact. 1.03. What is the ratio of the Value added (% of GDP) in Cameroon in 2009 to that in 2012?
Offer a terse response. 1.01. What is the ratio of the Value added (% of GDP) in Congo (Republic) in 2009 to that in 2012?
Make the answer very short. 1.15. What is the ratio of the Value added (% of GDP) of Kiribati in 2009 to that in 2012?
Provide a succinct answer. 0.98. What is the ratio of the Value added (% of GDP) in Congo (Republic) in 2010 to that in 2011?
Ensure brevity in your answer.  1.13. What is the ratio of the Value added (% of GDP) of Kiribati in 2010 to that in 2011?
Your response must be concise. 0.96. What is the ratio of the Value added (% of GDP) in Europe(developing only) in 2010 to that in 2012?
Your response must be concise. 1.05. What is the ratio of the Value added (% of GDP) of Cameroon in 2010 to that in 2012?
Offer a very short reply. 1.01. What is the ratio of the Value added (% of GDP) of Congo (Republic) in 2010 to that in 2012?
Give a very brief answer. 0.98. What is the ratio of the Value added (% of GDP) of Kiribati in 2010 to that in 2012?
Make the answer very short. 0.97. What is the ratio of the Value added (% of GDP) of Europe(developing only) in 2011 to that in 2012?
Offer a very short reply. 1.05. What is the ratio of the Value added (% of GDP) in Cameroon in 2011 to that in 2012?
Give a very brief answer. 1.02. What is the ratio of the Value added (% of GDP) in Congo (Republic) in 2011 to that in 2012?
Give a very brief answer. 0.86. What is the difference between the highest and the second highest Value added (% of GDP) of Europe(developing only)?
Offer a terse response. 1.24. What is the difference between the highest and the second highest Value added (% of GDP) in Cameroon?
Offer a very short reply. 0.09. What is the difference between the highest and the second highest Value added (% of GDP) in Congo (Republic)?
Ensure brevity in your answer.  0.04. What is the difference between the highest and the second highest Value added (% of GDP) of Kiribati?
Provide a succinct answer. 0.05. What is the difference between the highest and the lowest Value added (% of GDP) in Europe(developing only)?
Offer a terse response. 2.35. What is the difference between the highest and the lowest Value added (% of GDP) in Cameroon?
Your response must be concise. 2.98. What is the difference between the highest and the lowest Value added (% of GDP) of Congo (Republic)?
Keep it short and to the point. 1.16. What is the difference between the highest and the lowest Value added (% of GDP) in Kiribati?
Offer a terse response. 2.53. 